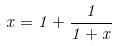<formula> <loc_0><loc_0><loc_500><loc_500>x = 1 + \frac { 1 } { 1 + x }</formula> 